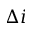Convert formula to latex. <formula><loc_0><loc_0><loc_500><loc_500>\Delta i</formula> 